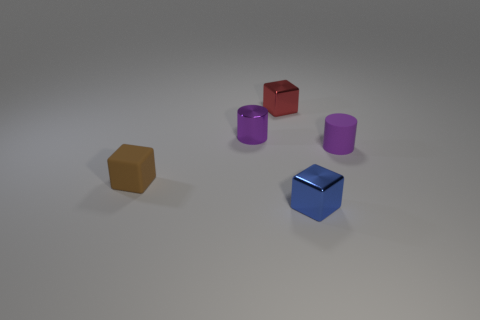Subtract all blue cubes. How many cubes are left? 2 Subtract all red blocks. How many blocks are left? 2 Add 5 shiny objects. How many objects exist? 10 Subtract all blocks. How many objects are left? 2 Subtract 1 cylinders. How many cylinders are left? 1 Subtract all blue cubes. Subtract all gray cylinders. How many cubes are left? 2 Subtract all purple balls. How many brown blocks are left? 1 Subtract all tiny blue blocks. Subtract all tiny purple metal objects. How many objects are left? 3 Add 5 small blocks. How many small blocks are left? 8 Add 4 small gray shiny cubes. How many small gray shiny cubes exist? 4 